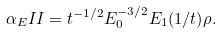<formula> <loc_0><loc_0><loc_500><loc_500>\alpha _ { E } I I = t ^ { - 1 / 2 } E _ { 0 } ^ { - 3 / 2 } E _ { 1 } ( 1 / t ) \rho .</formula> 